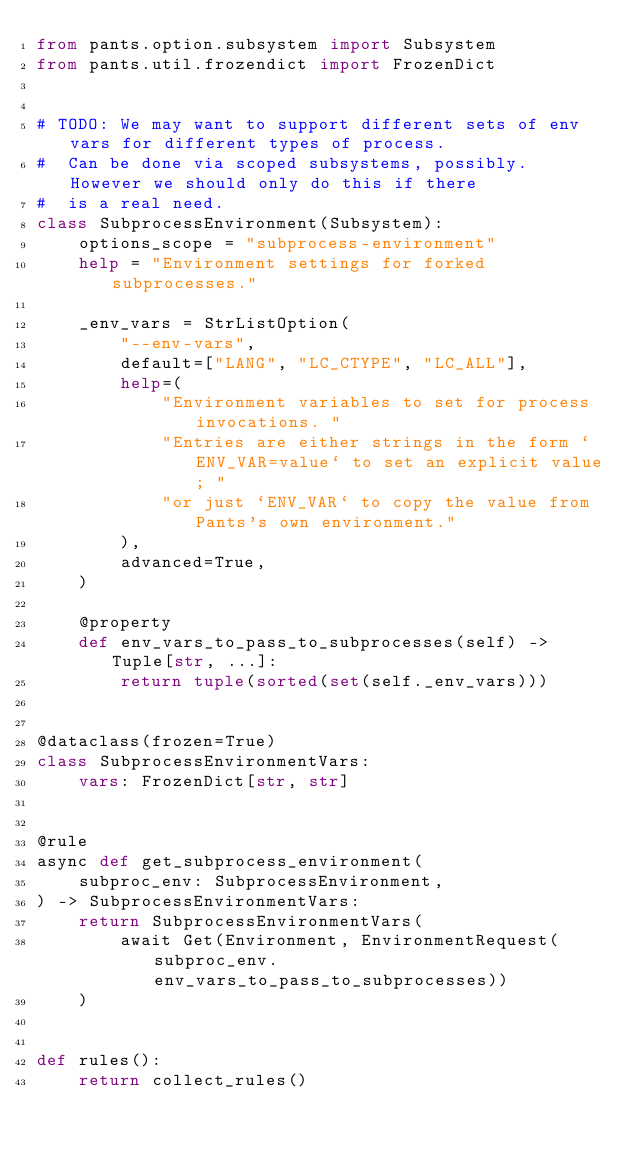Convert code to text. <code><loc_0><loc_0><loc_500><loc_500><_Python_>from pants.option.subsystem import Subsystem
from pants.util.frozendict import FrozenDict


# TODO: We may want to support different sets of env vars for different types of process.
#  Can be done via scoped subsystems, possibly.  However we should only do this if there
#  is a real need.
class SubprocessEnvironment(Subsystem):
    options_scope = "subprocess-environment"
    help = "Environment settings for forked subprocesses."

    _env_vars = StrListOption(
        "--env-vars",
        default=["LANG", "LC_CTYPE", "LC_ALL"],
        help=(
            "Environment variables to set for process invocations. "
            "Entries are either strings in the form `ENV_VAR=value` to set an explicit value; "
            "or just `ENV_VAR` to copy the value from Pants's own environment."
        ),
        advanced=True,
    )

    @property
    def env_vars_to_pass_to_subprocesses(self) -> Tuple[str, ...]:
        return tuple(sorted(set(self._env_vars)))


@dataclass(frozen=True)
class SubprocessEnvironmentVars:
    vars: FrozenDict[str, str]


@rule
async def get_subprocess_environment(
    subproc_env: SubprocessEnvironment,
) -> SubprocessEnvironmentVars:
    return SubprocessEnvironmentVars(
        await Get(Environment, EnvironmentRequest(subproc_env.env_vars_to_pass_to_subprocesses))
    )


def rules():
    return collect_rules()
</code> 